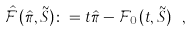Convert formula to latex. <formula><loc_0><loc_0><loc_500><loc_500>\hat { \mathcal { F } } ( \hat { \pi } , \tilde { S } ) \colon = t \hat { \pi } - \mathcal { F } _ { 0 } ( t , \tilde { S } ) \ ,</formula> 